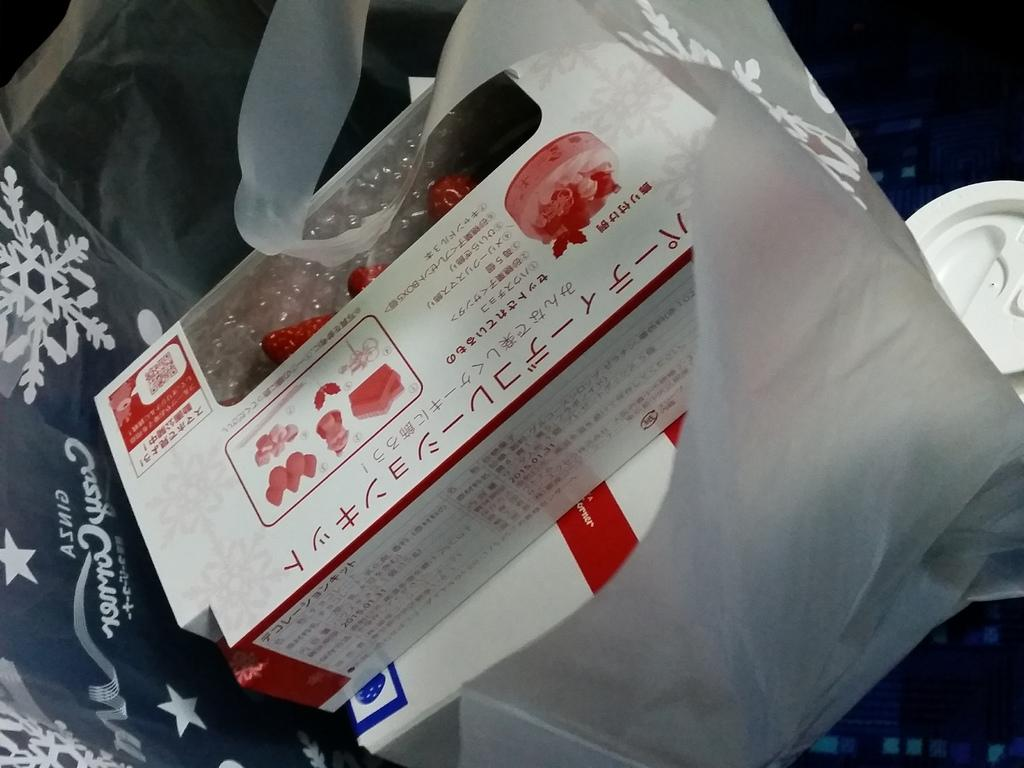What objects are present in the image? There are boxes in the image. What is covering the boxes? The boxes are covered in a plastic cover. How many feathers can be seen on the boxes in the image? There are no feathers present on the boxes in the image. What type of heat source is used to keep the boxes warm in the image? There is no heat source or indication of warmth in the image; it only shows boxes covered in a plastic cover. 